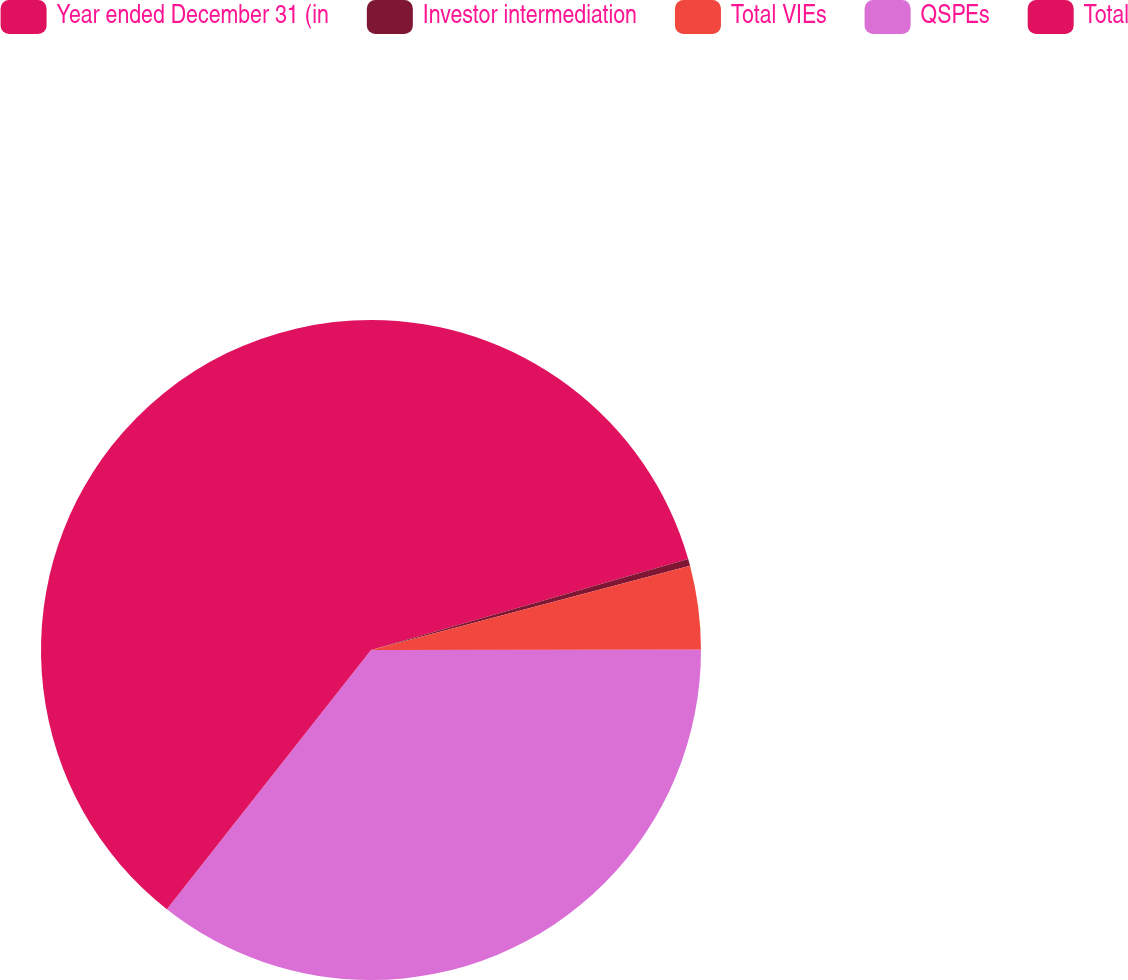<chart> <loc_0><loc_0><loc_500><loc_500><pie_chart><fcel>Year ended December 31 (in<fcel>Investor intermediation<fcel>Total VIEs<fcel>QSPEs<fcel>Total<nl><fcel>20.55%<fcel>0.34%<fcel>4.09%<fcel>35.63%<fcel>39.38%<nl></chart> 